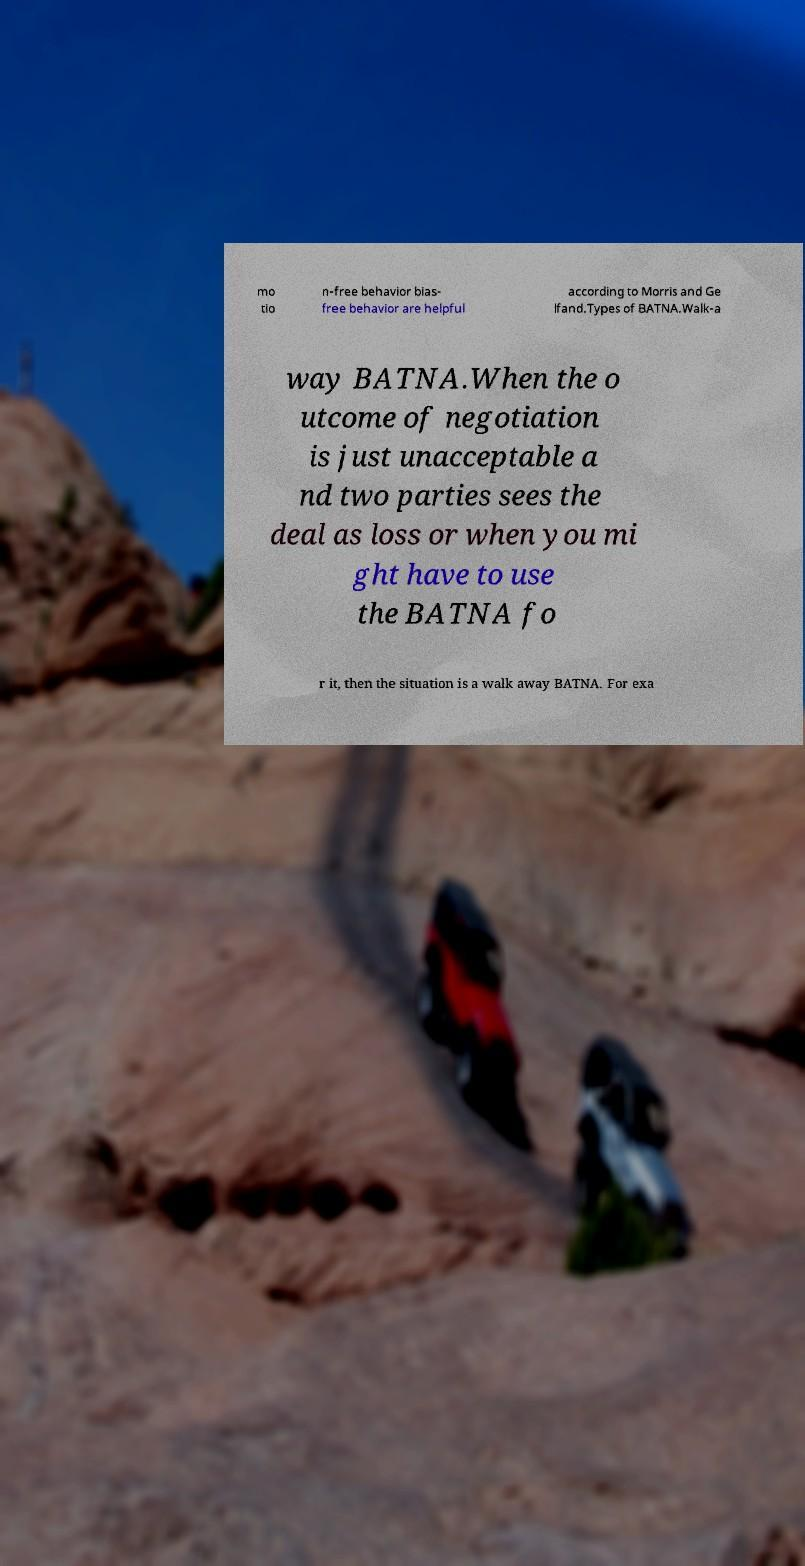For documentation purposes, I need the text within this image transcribed. Could you provide that? mo tio n-free behavior bias- free behavior are helpful according to Morris and Ge lfand.Types of BATNA.Walk-a way BATNA.When the o utcome of negotiation is just unacceptable a nd two parties sees the deal as loss or when you mi ght have to use the BATNA fo r it, then the situation is a walk away BATNA. For exa 